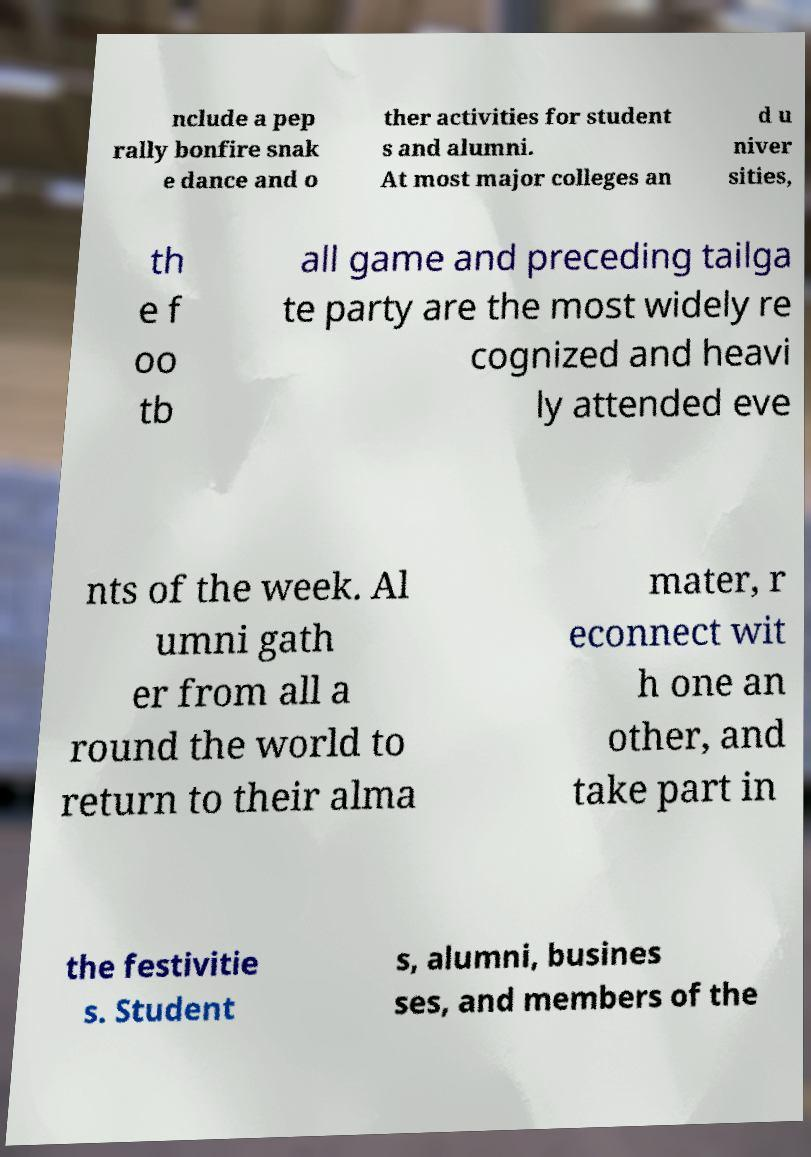Could you extract and type out the text from this image? nclude a pep rally bonfire snak e dance and o ther activities for student s and alumni. At most major colleges an d u niver sities, th e f oo tb all game and preceding tailga te party are the most widely re cognized and heavi ly attended eve nts of the week. Al umni gath er from all a round the world to return to their alma mater, r econnect wit h one an other, and take part in the festivitie s. Student s, alumni, busines ses, and members of the 